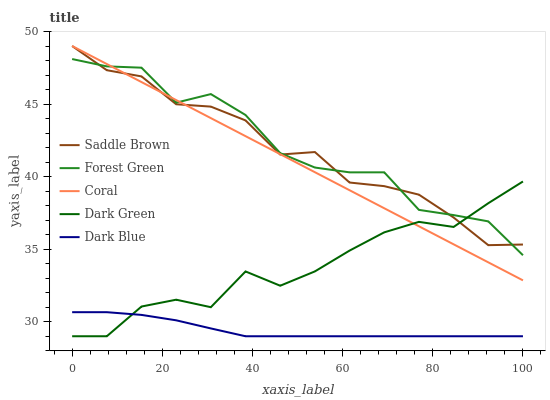Does Dark Blue have the minimum area under the curve?
Answer yes or no. Yes. Does Forest Green have the maximum area under the curve?
Answer yes or no. Yes. Does Forest Green have the minimum area under the curve?
Answer yes or no. No. Does Dark Blue have the maximum area under the curve?
Answer yes or no. No. Is Coral the smoothest?
Answer yes or no. Yes. Is Forest Green the roughest?
Answer yes or no. Yes. Is Dark Blue the smoothest?
Answer yes or no. No. Is Dark Blue the roughest?
Answer yes or no. No. Does Dark Blue have the lowest value?
Answer yes or no. Yes. Does Forest Green have the lowest value?
Answer yes or no. No. Does Saddle Brown have the highest value?
Answer yes or no. Yes. Does Forest Green have the highest value?
Answer yes or no. No. Is Dark Blue less than Forest Green?
Answer yes or no. Yes. Is Forest Green greater than Dark Blue?
Answer yes or no. Yes. Does Dark Green intersect Coral?
Answer yes or no. Yes. Is Dark Green less than Coral?
Answer yes or no. No. Is Dark Green greater than Coral?
Answer yes or no. No. Does Dark Blue intersect Forest Green?
Answer yes or no. No. 